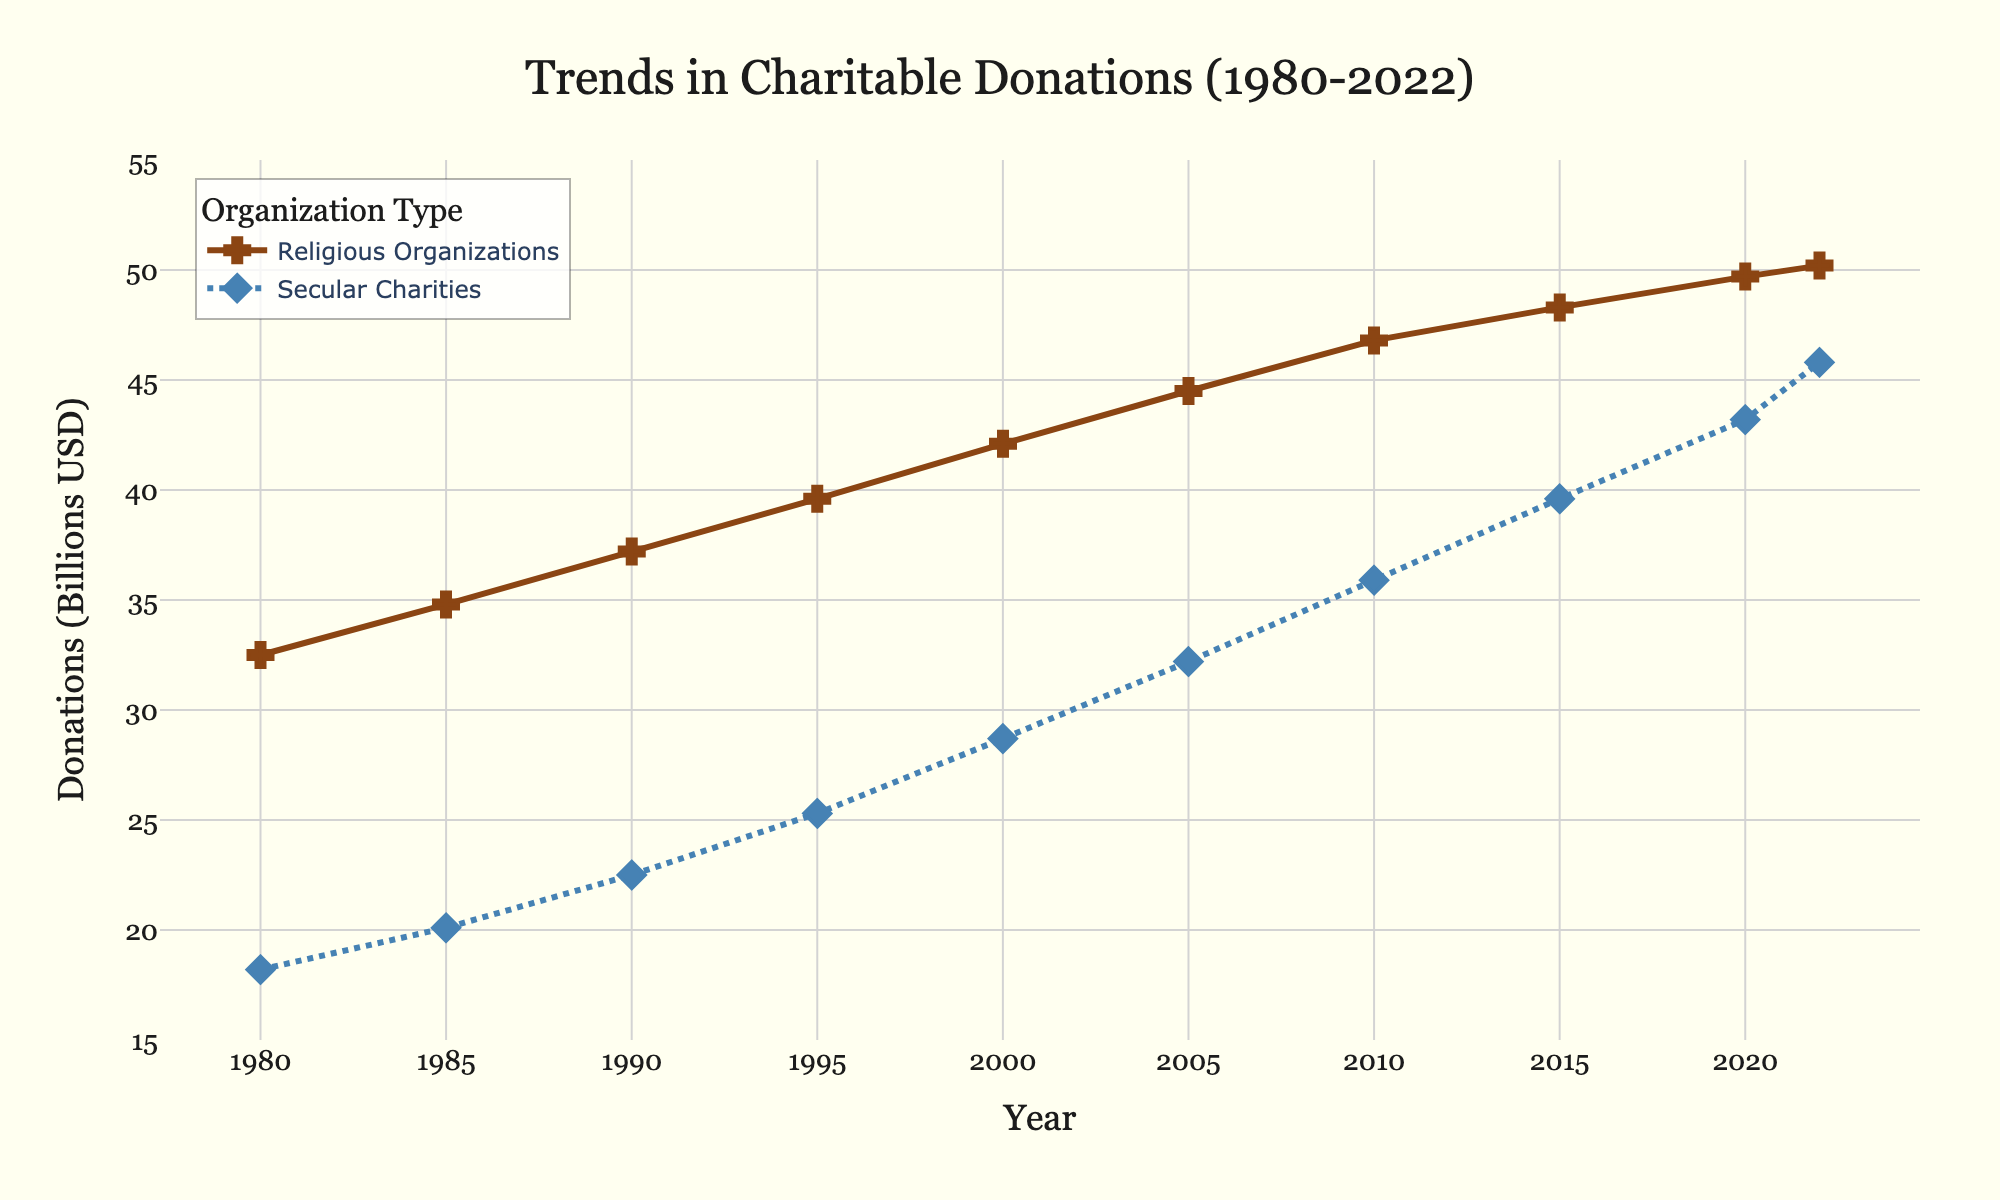What year did donations to religious organizations surpass $40 billion? The chart shows donations to religious organizations and secular charities over time. Locate the point where the line representing religious organizations crosses the $40 billion mark on the y-axis. This occurs around the year 2000.
Answer: 2000 What is the difference in donations between religious organizations and secular charities in 2022? Identify the value for each organization in 2022: religious organizations at $50.2 billion and secular charities at $45.8 billion. Subtract the latter from the former: $50.2 - $45.8 = $4.4 billion.
Answer: $4.4 billion In which year was the smallest gap between donations to religious organizations and secular charities? Observe the graph to identify the years where the lines representing both organizations are closest to each other. The smallest gap appears to be in 2022.
Answer: 2022 How much did donations to secular charities increase from 1980 to 2022? Find the donation values for secular charities in 1980 and 2022, which are $18.2 billion and $45.8 billion respectively. Calculate the increase: $45.8 - $18.2 = $27.6 billion.
Answer: $27.6 billion Compare the growth rates of donations to religious organizations and secular charities between 1980 and 2022. Calculate the growth rate for each: Religious organizations grew from $32.5 billion to $50.2 billion, and secular charities from $18.2 billion to $45.8 billion. Growth rates are (50.2-32.5)/32.5 ≈ 0.54 or 54% for religious organizations and (45.8-18.2)/18.2 ≈ 1.52 or 152% for secular charities.
Answer: Secular charities grew faster When did donations to religious organizations first exceed $45 billion? Information from the chart shows religious organizations exceeding $45 billion between 2005 and 2010. Pinpoint the exact year: 2010.
Answer: 2010 What is the linear trend in donations to religious organizations from 1980 to 2022? Observe the line for religious organizations, which shows an upward trend. Calculate the overall increase: $50.2 billion (2022) - $32.5 billion (1980) = $17.7 billion. The annual increase is approximately $17.7 billion / 42 years ≈ $0.42 billion per year.
Answer: $0.42 billion per year Which organization's donations were growing at a faster rate between 1980 and 2000? By examining the slopes of the lines from 1980 to 2000, secular charities increased from $18.2 billion to $28.7 billion, and religious organizations from $32.5 billion to $42.1 billion. Growth for secular charities: $28.7 - $18.2 = $10.5 billion, and religious organizations: $42.1 - $32.5 = $9.6 billion. Secular charities grew faster.
Answer: Secular charities How much did donations to religious organizations increase from 2000 to 2022 compared to secular charities? Find the donation values in 2000 and 2022 for both organizations: Religious organizations grew from $42.1 billion to $50.2 billion (increase $8.1 billion). Secular charities from $28.7 billion to $45.8 billion (increase $17.1 billion). Compare increases: $8.1 billion vs $17.1 billion.
Answer: Secular charities increased more What is the trend in donations to secular charities from 1985 to 2010? Observe donations for secular charities in 1985 ($20.1 billion) and in 2010 ($35.9 billion). The overall trend is upward. Calculate the increase: $35.9 billion - $20.1 billion = $15.8 billion over 25 years.
Answer: Upward trend 